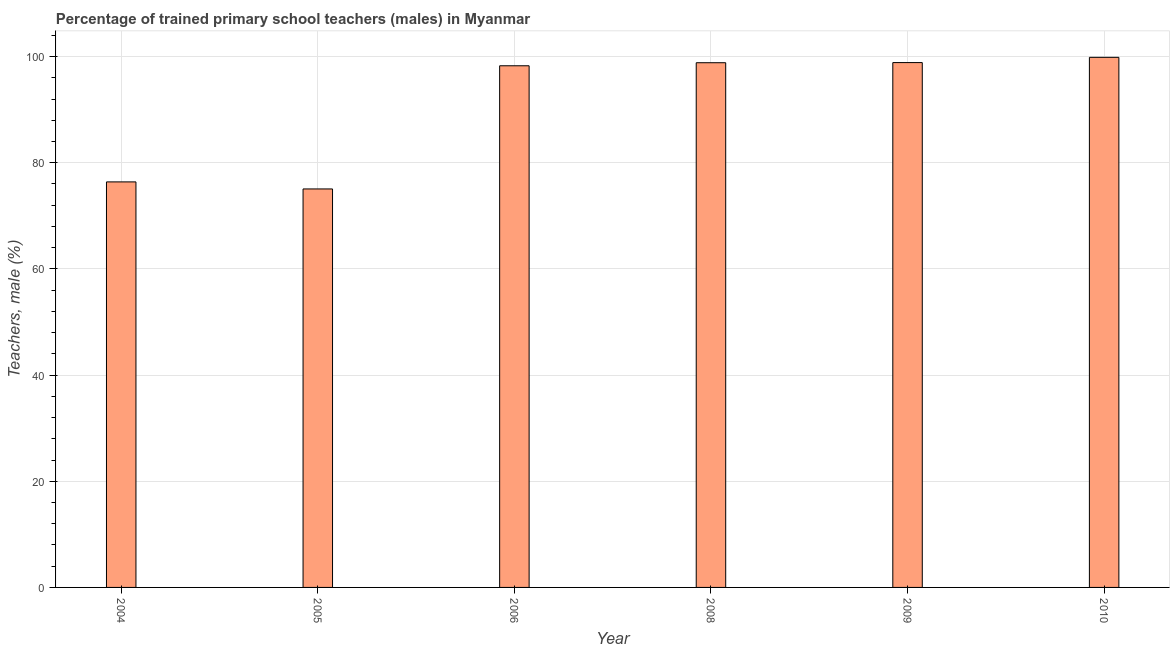What is the title of the graph?
Provide a short and direct response. Percentage of trained primary school teachers (males) in Myanmar. What is the label or title of the X-axis?
Make the answer very short. Year. What is the label or title of the Y-axis?
Your answer should be very brief. Teachers, male (%). What is the percentage of trained male teachers in 2009?
Give a very brief answer. 98.87. Across all years, what is the maximum percentage of trained male teachers?
Your answer should be very brief. 99.86. Across all years, what is the minimum percentage of trained male teachers?
Make the answer very short. 75.07. In which year was the percentage of trained male teachers maximum?
Offer a terse response. 2010. In which year was the percentage of trained male teachers minimum?
Make the answer very short. 2005. What is the sum of the percentage of trained male teachers?
Provide a short and direct response. 547.31. What is the difference between the percentage of trained male teachers in 2006 and 2010?
Make the answer very short. -1.59. What is the average percentage of trained male teachers per year?
Offer a terse response. 91.22. What is the median percentage of trained male teachers?
Your response must be concise. 98.56. What is the ratio of the percentage of trained male teachers in 2008 to that in 2009?
Provide a succinct answer. 1. Is the difference between the percentage of trained male teachers in 2006 and 2008 greater than the difference between any two years?
Offer a terse response. No. Is the sum of the percentage of trained male teachers in 2004 and 2006 greater than the maximum percentage of trained male teachers across all years?
Provide a short and direct response. Yes. What is the difference between the highest and the lowest percentage of trained male teachers?
Provide a short and direct response. 24.79. How many bars are there?
Your answer should be very brief. 6. Are all the bars in the graph horizontal?
Make the answer very short. No. What is the difference between two consecutive major ticks on the Y-axis?
Provide a succinct answer. 20. Are the values on the major ticks of Y-axis written in scientific E-notation?
Your response must be concise. No. What is the Teachers, male (%) of 2004?
Provide a short and direct response. 76.39. What is the Teachers, male (%) in 2005?
Provide a short and direct response. 75.07. What is the Teachers, male (%) of 2006?
Keep it short and to the point. 98.27. What is the Teachers, male (%) of 2008?
Your response must be concise. 98.84. What is the Teachers, male (%) in 2009?
Your answer should be compact. 98.87. What is the Teachers, male (%) in 2010?
Give a very brief answer. 99.86. What is the difference between the Teachers, male (%) in 2004 and 2005?
Make the answer very short. 1.33. What is the difference between the Teachers, male (%) in 2004 and 2006?
Ensure brevity in your answer.  -21.88. What is the difference between the Teachers, male (%) in 2004 and 2008?
Your answer should be very brief. -22.45. What is the difference between the Teachers, male (%) in 2004 and 2009?
Give a very brief answer. -22.48. What is the difference between the Teachers, male (%) in 2004 and 2010?
Ensure brevity in your answer.  -23.47. What is the difference between the Teachers, male (%) in 2005 and 2006?
Give a very brief answer. -23.2. What is the difference between the Teachers, male (%) in 2005 and 2008?
Offer a very short reply. -23.78. What is the difference between the Teachers, male (%) in 2005 and 2009?
Ensure brevity in your answer.  -23.8. What is the difference between the Teachers, male (%) in 2005 and 2010?
Provide a short and direct response. -24.79. What is the difference between the Teachers, male (%) in 2006 and 2008?
Provide a succinct answer. -0.57. What is the difference between the Teachers, male (%) in 2006 and 2009?
Keep it short and to the point. -0.6. What is the difference between the Teachers, male (%) in 2006 and 2010?
Make the answer very short. -1.59. What is the difference between the Teachers, male (%) in 2008 and 2009?
Offer a terse response. -0.03. What is the difference between the Teachers, male (%) in 2008 and 2010?
Provide a short and direct response. -1.02. What is the difference between the Teachers, male (%) in 2009 and 2010?
Your answer should be compact. -0.99. What is the ratio of the Teachers, male (%) in 2004 to that in 2006?
Offer a terse response. 0.78. What is the ratio of the Teachers, male (%) in 2004 to that in 2008?
Your answer should be compact. 0.77. What is the ratio of the Teachers, male (%) in 2004 to that in 2009?
Provide a succinct answer. 0.77. What is the ratio of the Teachers, male (%) in 2004 to that in 2010?
Offer a very short reply. 0.77. What is the ratio of the Teachers, male (%) in 2005 to that in 2006?
Provide a short and direct response. 0.76. What is the ratio of the Teachers, male (%) in 2005 to that in 2008?
Offer a very short reply. 0.76. What is the ratio of the Teachers, male (%) in 2005 to that in 2009?
Make the answer very short. 0.76. What is the ratio of the Teachers, male (%) in 2005 to that in 2010?
Ensure brevity in your answer.  0.75. What is the ratio of the Teachers, male (%) in 2006 to that in 2009?
Your response must be concise. 0.99. What is the ratio of the Teachers, male (%) in 2006 to that in 2010?
Provide a short and direct response. 0.98. What is the ratio of the Teachers, male (%) in 2008 to that in 2010?
Ensure brevity in your answer.  0.99. 